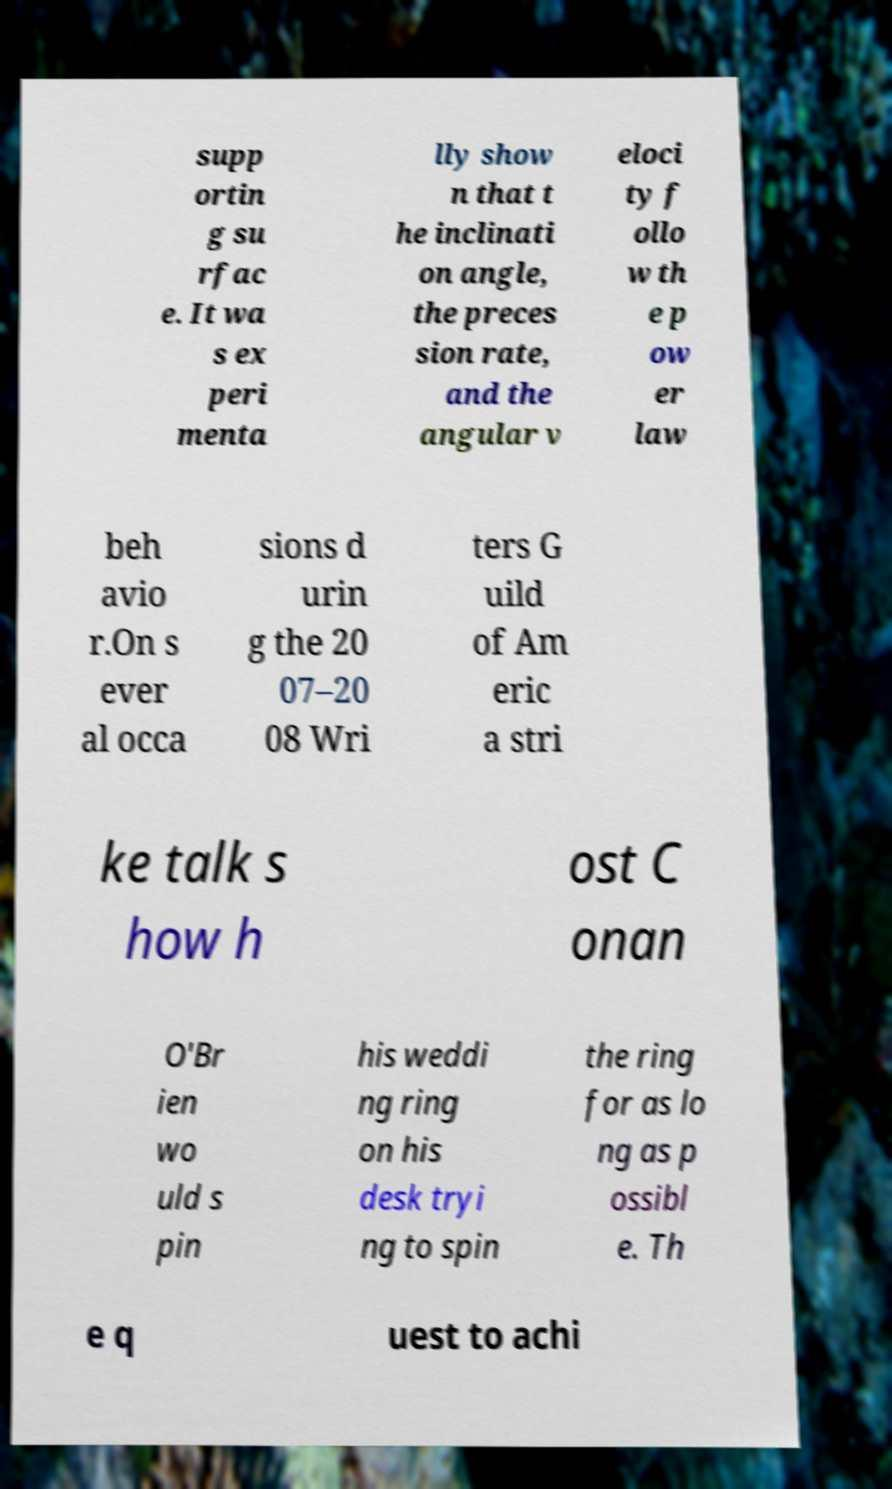Could you assist in decoding the text presented in this image and type it out clearly? supp ortin g su rfac e. It wa s ex peri menta lly show n that t he inclinati on angle, the preces sion rate, and the angular v eloci ty f ollo w th e p ow er law beh avio r.On s ever al occa sions d urin g the 20 07–20 08 Wri ters G uild of Am eric a stri ke talk s how h ost C onan O'Br ien wo uld s pin his weddi ng ring on his desk tryi ng to spin the ring for as lo ng as p ossibl e. Th e q uest to achi 